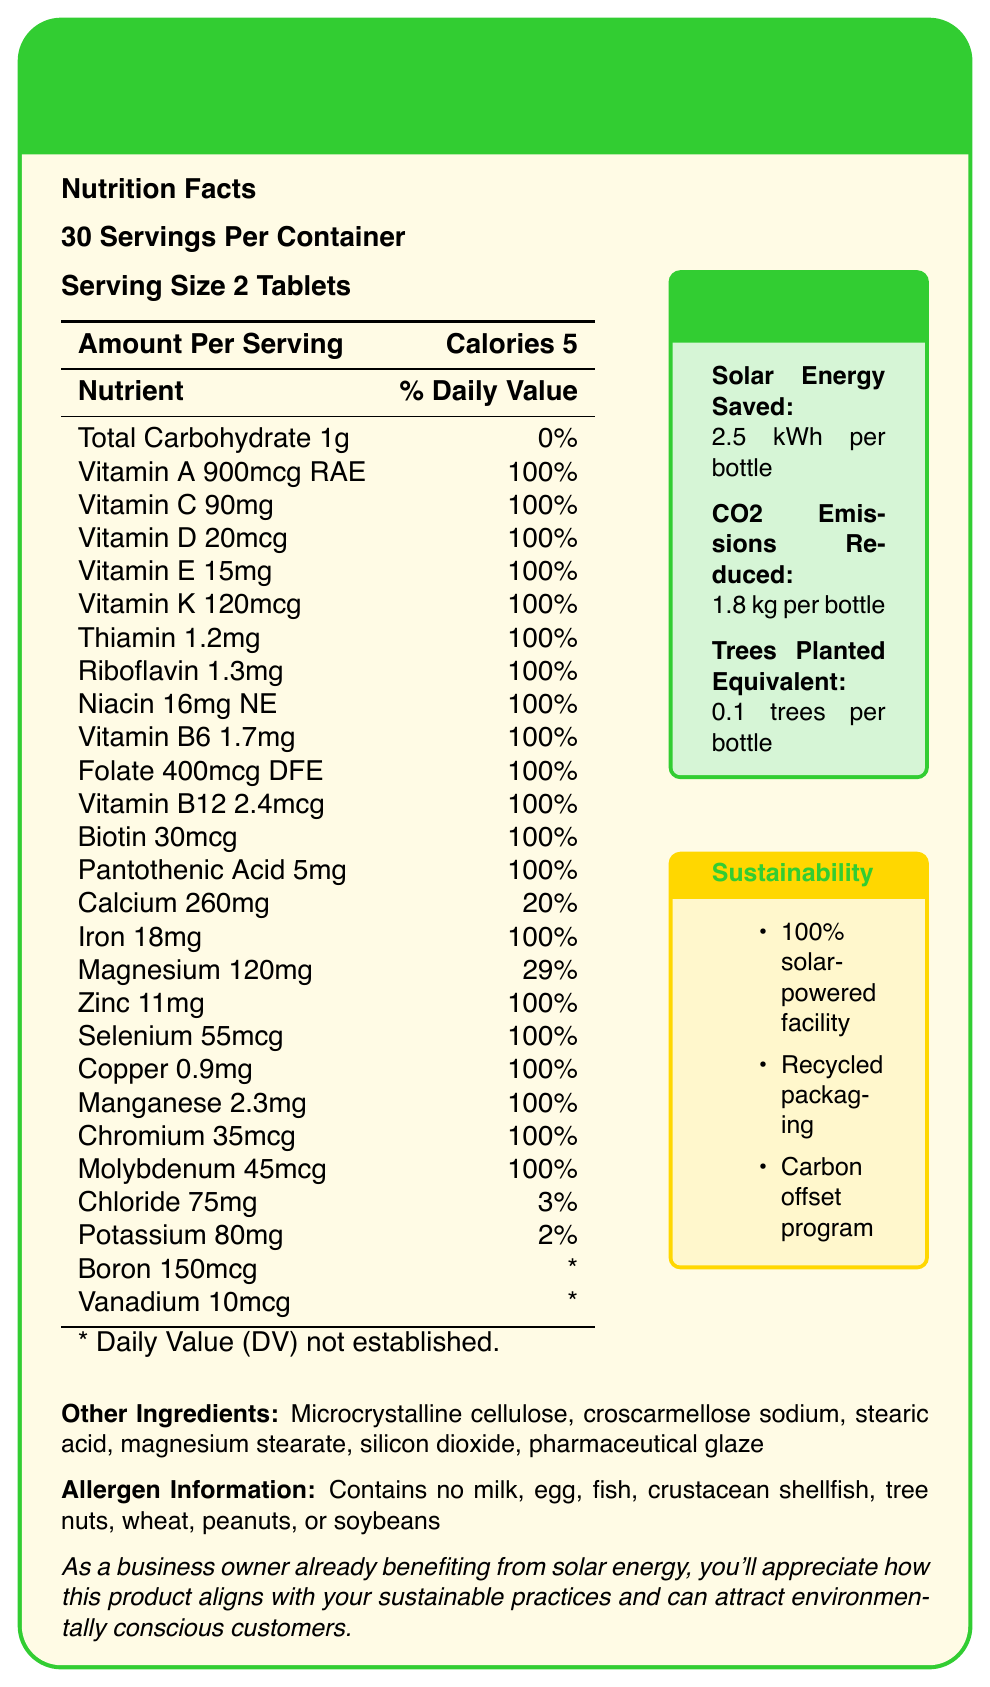what is the serving size of SolarBoost Green Energy Multivitamin? The serving size is explicitly mentioned as "2 tablets" in the document.
Answer: 2 tablets how many calories does one serving of SolarBoost Green Energy Multivitamin contain? The document states "Calories 5" under the Amount Per Serving section.
Answer: 5 Does SolarBoost Green Energy Multivitamin contain any milk or egg allergens? The allergen information specifies that the product contains no milk, egg, fish, crustacean shellfish, tree nuts, wheat, peanuts, or soybeans.
Answer: No how many servings per container are there? The document mentions "30 Servings Per Container."
Answer: 30 What is the daily percentage value of Iron offered by one serving? The document shows "Iron 18mg (100% DV)" indicating 100% of the daily value.
Answer: 100% What is the environmental benefit of purchasing one bottle in terms of CO2 emissions reduced? The Environmental Benefits box lists "CO2 Emissions Reduced: 1.8 kg per bottle."
Answer: 1.8 kg per bottle What percentage of the daily value of Vitamin C is in each serving of SolarBoost Green Energy Multivitamin? A. 50% B. 75% C. 100% D. 150% The document states "Vitamin C 90mg (100% DV)."
Answer: C Which of the following facilities does the manufacturing of SolarBoost Green Energy Multivitamin use? A. Coal-powered facility B. 100% solar-powered facility C. Natural gas-powered facility D. Mixed-energy facility The document clearly states that the product is "Produced in a solar-powered facility using 100% renewable energy."
Answer: B What is the amount of Zinc per serving? A. 5mg B. 8mg C. 11mg D. 14mg The document lists "Zinc 11mg (100% DV)," so the correct amount is 11mg.
Answer: C Using the nutritional information, what percentage of daily value of Calcium does one serving provide? The document lists "Calcium 260mg (20% DV)."
Answer: 20% DV Is the packaging of SolarBoost Green Energy Multivitamin eco-friendly? The document mentions "100% recycled and recyclable materials" for packaging.
Answer: Yes Summarize the main environmental benefits highlighted for the SolarBoost Green Energy Multivitamin. The document highlights that each bottle of SolarBoost Green Energy Multivitamin saves 2.5 kWh of solar energy, reduces CO2 emissions by 1.8 kg, and is equivalent to planting 0.1 trees. The product is made in a solar-powered facility, uses 100% recycled packaging materials, and has a carbon offset program supporting solar panel installations in developing countries.
Answer: The product saves 2.5 kWh of solar energy per bottle, reduces 1.8 kg of CO2 emissions per bottle, and is equivalent to planting 0.1 trees per bottle. Additionally, it is produced in a 100% solar-powered facility, uses recycled packaging, and contributes to solar panel installations in developing countries. What percentage of total carbohydrates is available in one serving of SolarBoost Green Energy Multivitamin? The document lists "Total Carbohydrate 1g & 0%" indicating no significant daily value percentage for carbohydrates.
Answer: 0% Does the SolarBoost Green Energy Multivitamin production contribute to carbon offsets? It is mentioned that "Each purchase contributes to solar panel installations in developing countries."
Answer: Yes What is the Boron content per serving in SolarBoost Green Energy Multivitamin? The document lists "Boron 150mcg" without a daily value percentage.
Answer: 150mcg Is the main idea of the SolarBoost Green Energy Multivitamin document more about its nutritional benefits or its environmental impact? The document extensively highlights both the nutritional content and various environmental benefits, such as energy savings, CO2 reduction, and sustainability practices.
Answer: Both, but it largely emphasizes the environmental benefits. What is the company's strategy in aligning this product with sustainable practices specifically targeting customers like yourself? The document includes a statement that the product aligns with sustainable practices such as being produced using 100% renewable energy, using recycled packaging, and having a carbon offset program, which would attract environmentally conscious customers.
Answer: Emphasizing sustainability and environmental benefits while offering full daily value nutrition. How many micrograms (mcg) of Vitamin K are present per serving? The document lists "Vitamin K 120mcg (100% DV)."
Answer: 120mcg What other ingredient in the SolarBoost Green Energy Multivitamin could be linked with aiding tablet disintegration? Among the listed other ingredients, croscarmellose sodium is known to be used for tablet disintegration.
Answer: Croscarmellose sodium 